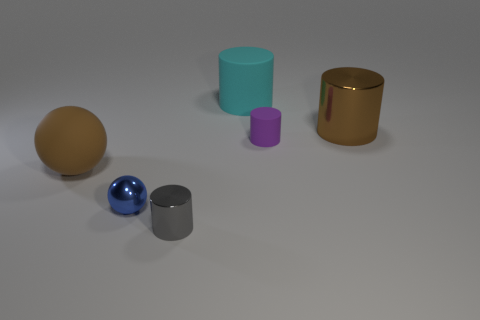Subtract all red cylinders. Subtract all blue spheres. How many cylinders are left? 4 Add 4 big cylinders. How many objects exist? 10 Subtract all spheres. How many objects are left? 4 Subtract all tiny metallic balls. Subtract all small metallic cylinders. How many objects are left? 4 Add 5 metal cylinders. How many metal cylinders are left? 7 Add 4 large shiny objects. How many large shiny objects exist? 5 Subtract 0 red cubes. How many objects are left? 6 